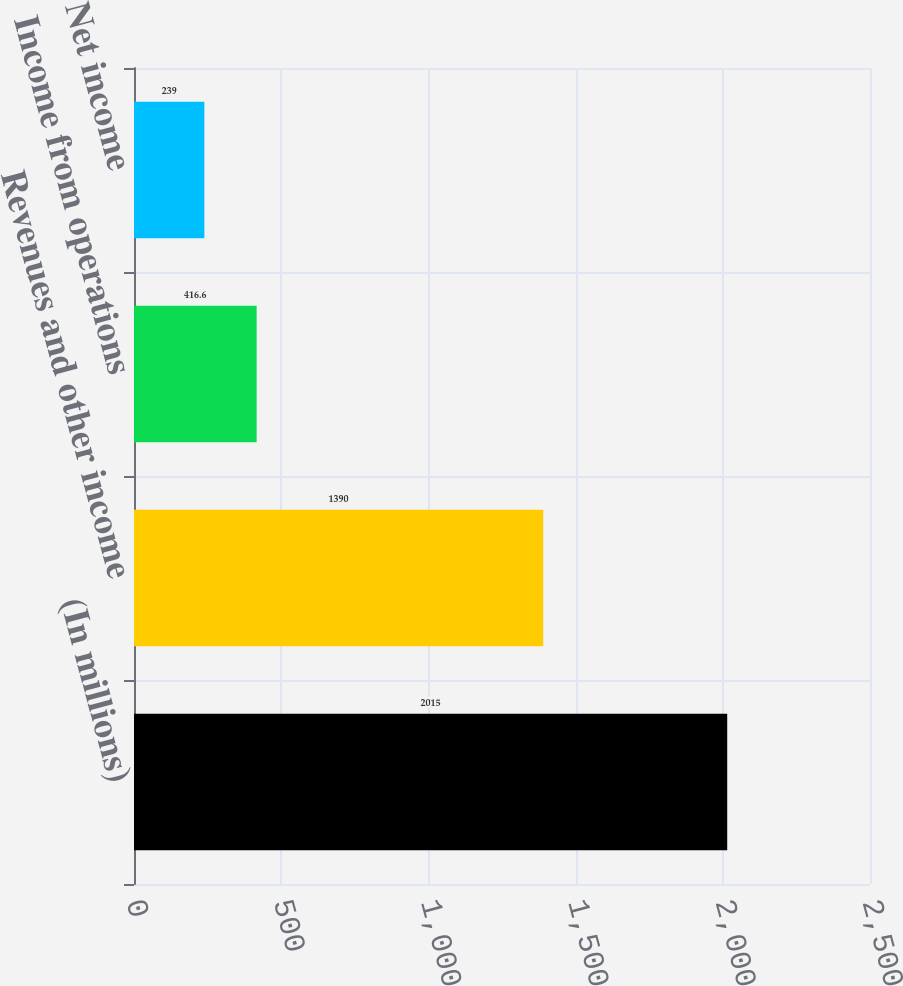Convert chart. <chart><loc_0><loc_0><loc_500><loc_500><bar_chart><fcel>(In millions)<fcel>Revenues and other income<fcel>Income from operations<fcel>Net income<nl><fcel>2015<fcel>1390<fcel>416.6<fcel>239<nl></chart> 